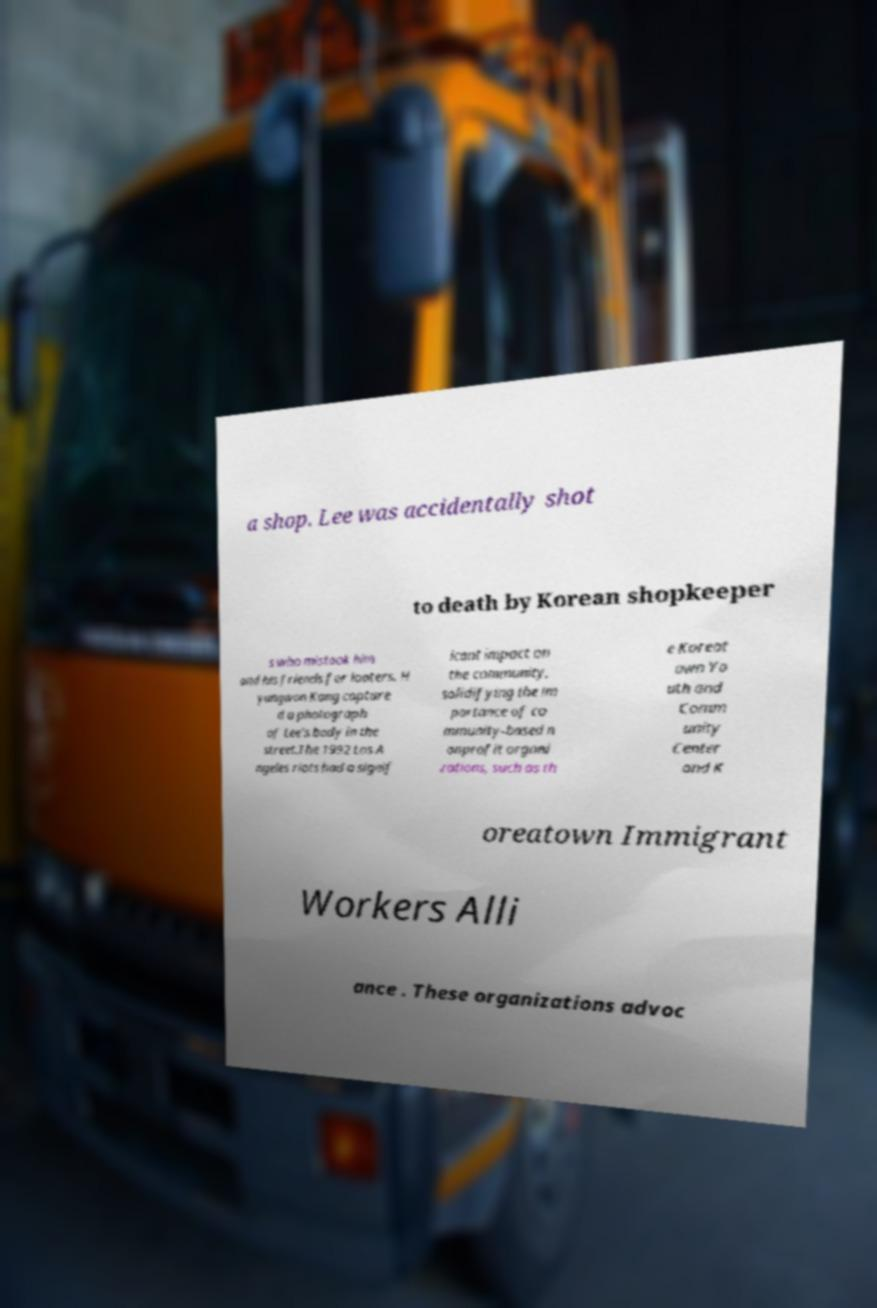Can you accurately transcribe the text from the provided image for me? a shop. Lee was accidentally shot to death by Korean shopkeeper s who mistook him and his friends for looters. H yungwon Kang capture d a photograph of Lee's body in the street.The 1992 Los A ngeles riots had a signif icant impact on the community, solidifying the im portance of co mmunity-based n onprofit organi zations, such as th e Koreat own Yo uth and Comm unity Center and K oreatown Immigrant Workers Alli ance . These organizations advoc 